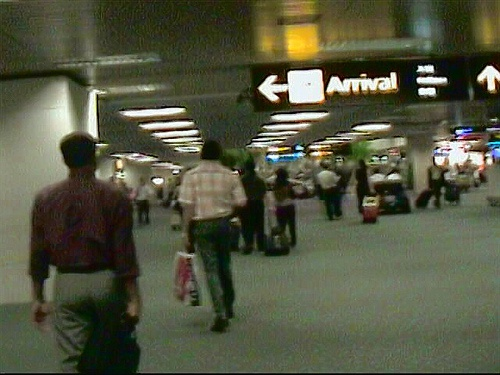Describe the objects in this image and their specific colors. I can see people in gray, black, and darkgreen tones, people in gray and black tones, handbag in gray, black, and darkgreen tones, people in gray, black, and darkgreen tones, and people in gray, black, and darkgreen tones in this image. 